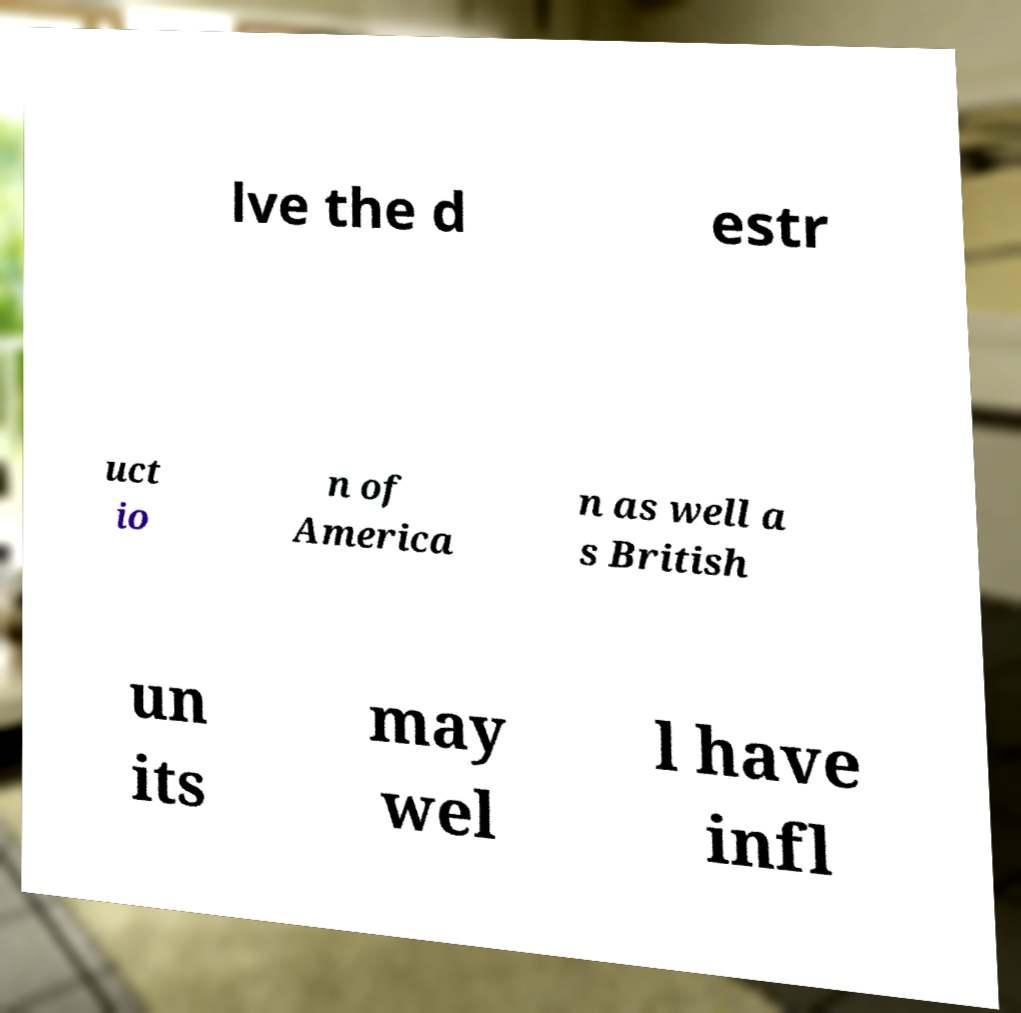Please read and relay the text visible in this image. What does it say? lve the d estr uct io n of America n as well a s British un its may wel l have infl 